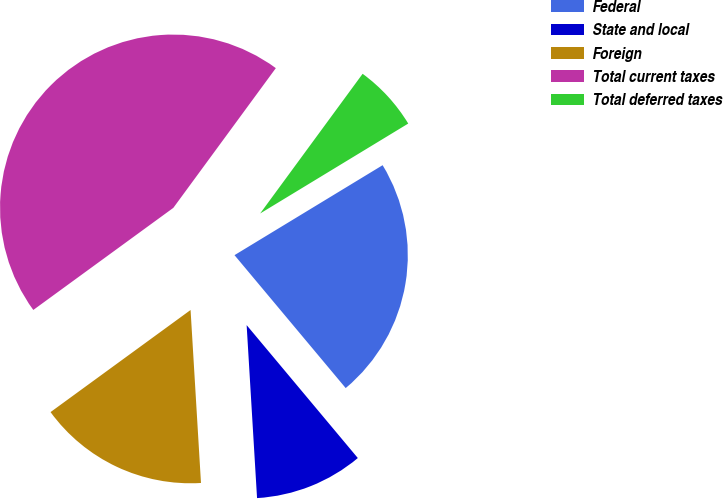Convert chart. <chart><loc_0><loc_0><loc_500><loc_500><pie_chart><fcel>Federal<fcel>State and local<fcel>Foreign<fcel>Total current taxes<fcel>Total deferred taxes<nl><fcel>22.6%<fcel>10.13%<fcel>15.93%<fcel>45.1%<fcel>6.24%<nl></chart> 